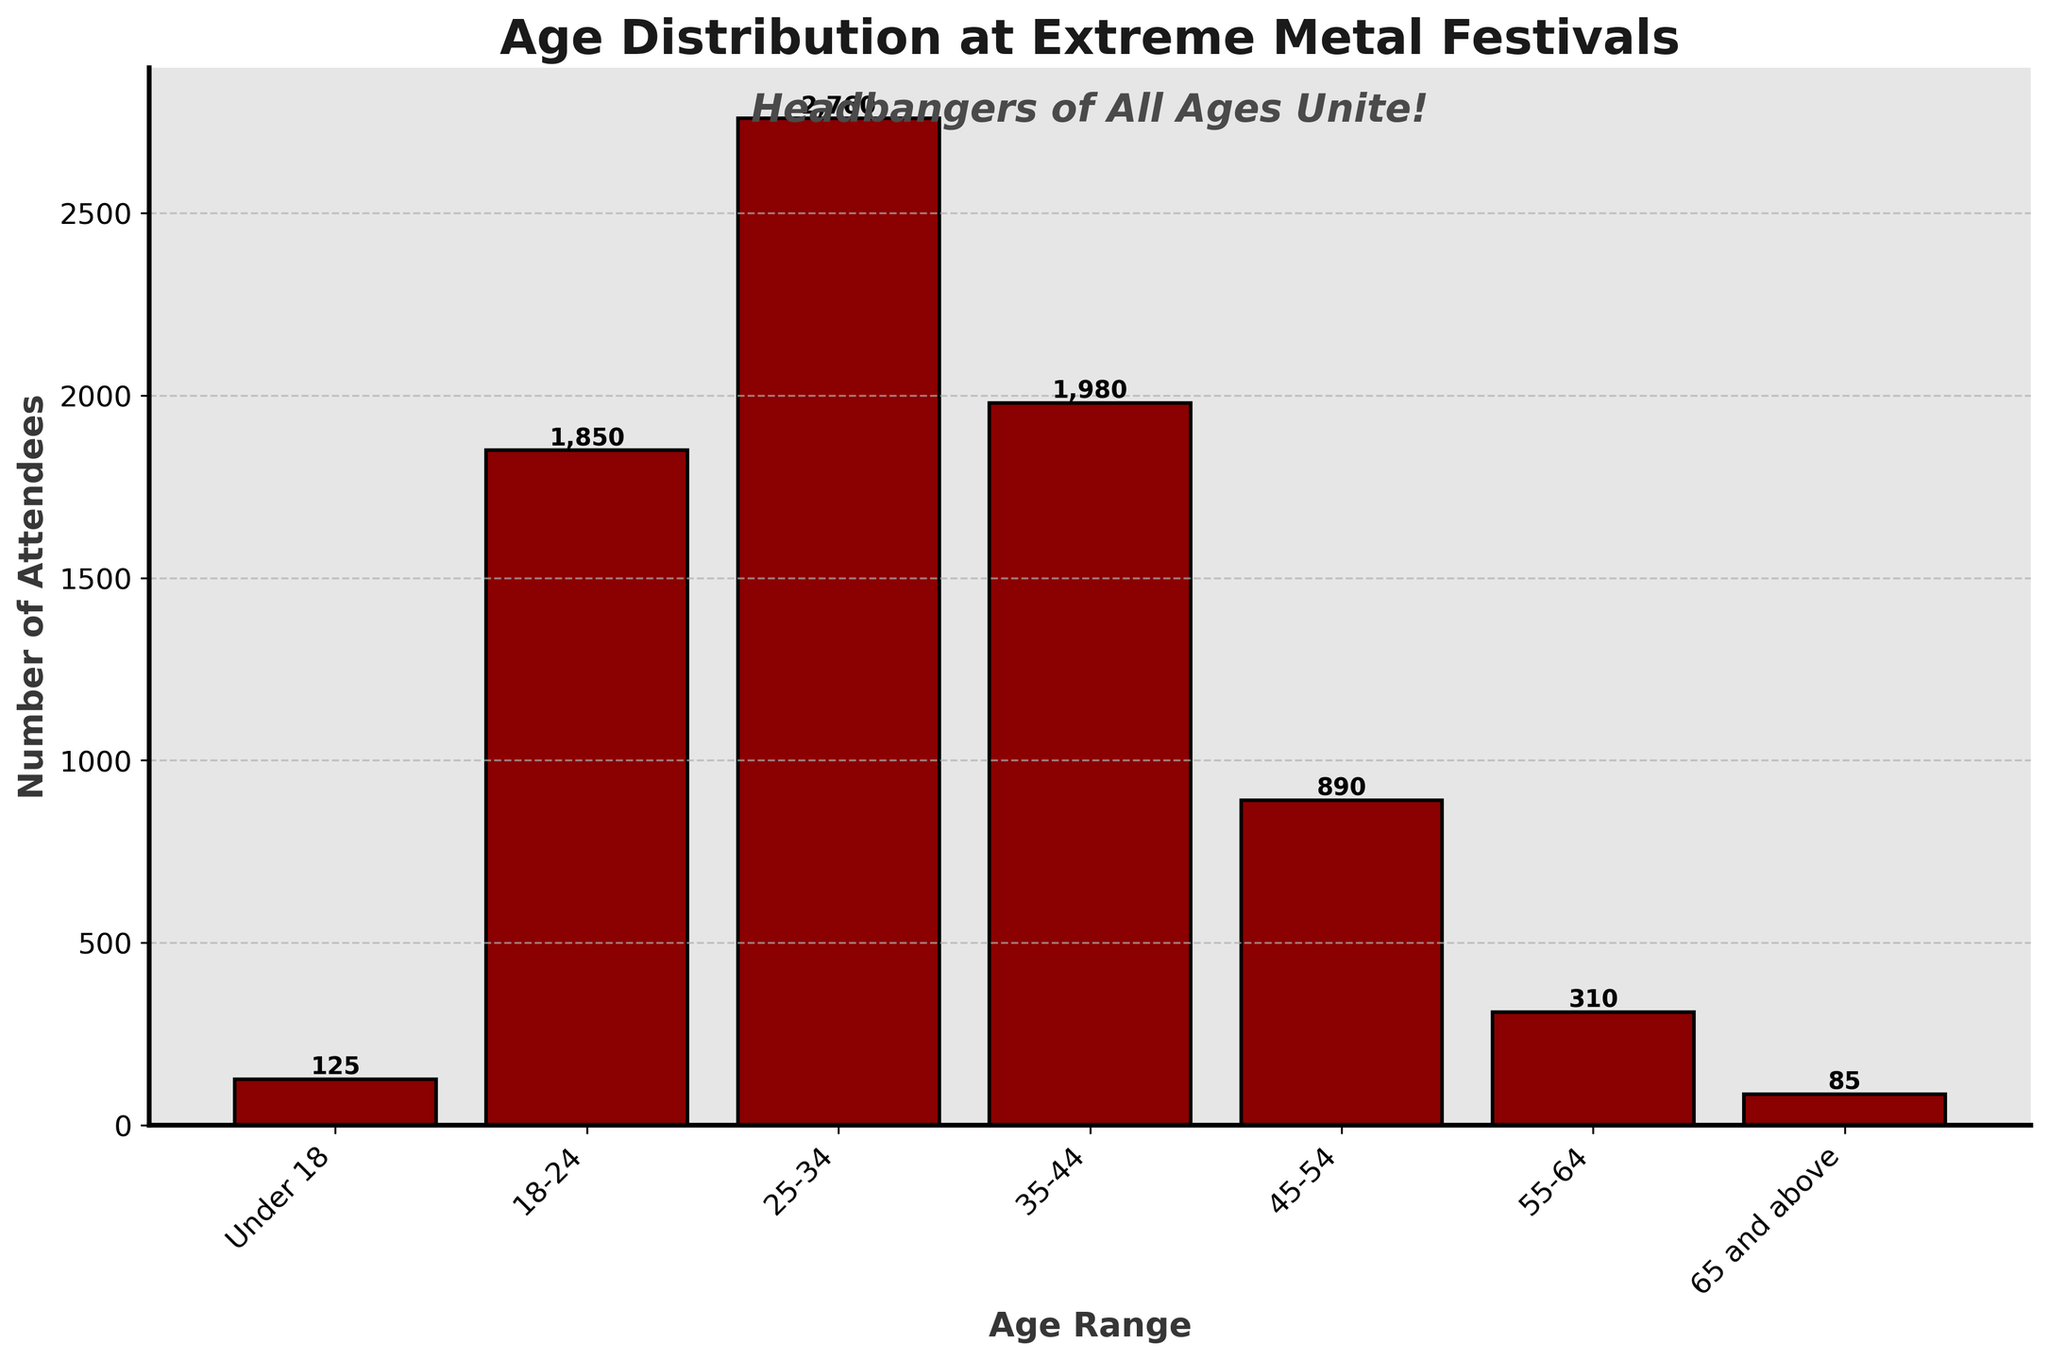What is the title of the figure? The title of the figure is typically displayed at the top of the plot. It provides a summary of what the figure represents. In this case, it says "Age Distribution at Extreme Metal Festivals"
Answer: Age Distribution at Extreme Metal Festivals How many age ranges are represented in the histogram? To find the number of age ranges, count the number of different bars or categories on the x-axis. Here the age ranges are: "Under 18", "18-24", "25-34", "35-44", "45-54", "55-64", and "65 and above".
Answer: 7 Which age range has the highest number of attendees? Look for the tallest bar in the histogram. The tallest bar represents the age range with the most attendees. Here, the 25-34 age range has the highest number of attendees.
Answer: 25-34 What is the number of attendees in the 55-64 age range? Locate the bar that corresponds to the 55-64 age range and read its height. The height of this bar indicates the number of attendees.
Answer: 310 How does the number of attendees in the "Under 18" range compare to the "65 and above" range? Compare the heights of the bars corresponding to the "Under 18" and "65 and above" age ranges. The "Under 18" bar is taller, indicating more attendees.
Answer: "Under 18" has more attendees What is the total number of attendees across all age ranges? Add the attendee numbers for all age ranges: 125 (Under 18) + 1850 (18-24) + 2760 (25-34) + 1980 (35-44) + 890 (45-54) + 310 (55-64) + 85 (65 and above). The total sum is the total number of attendees.
Answer: 8000 What approximate percentage of total attendees are in the 25-34 age range? First, find the proportion of attendees in the 25-34 range: 2760 (25-34) / 8000 (total). Then, multiply by 100 to convert to a percentage. 2760 / 8000 ≈ 0.345, and 0.345 * 100 ≈ 34.5%.
Answer: 34.5% What proportion of the attendees are 45 years and older? Sum the attendees in the age ranges 45-54, 55-64, and 65 and above: 890 + 310 + 85 = 1285. Then, divide by the total number of attendees: 1285 / 8000 ≈ 0.160. The proportion is approximately 16%.
Answer: 16% Which age range has the second-highest number of attendees? Identify the bars in the histogram and note their heights. The second-highest bar is for the age range 35-44, which has the second-highest number of attendees after 25-34.
Answer: 35-44 